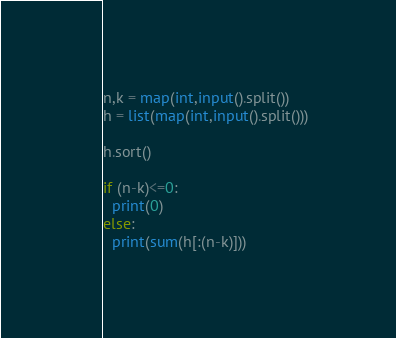Convert code to text. <code><loc_0><loc_0><loc_500><loc_500><_Python_>n,k = map(int,input().split())
h = list(map(int,input().split()))

h.sort()

if (n-k)<=0:
  print(0)
else:
  print(sum(h[:(n-k)]))</code> 